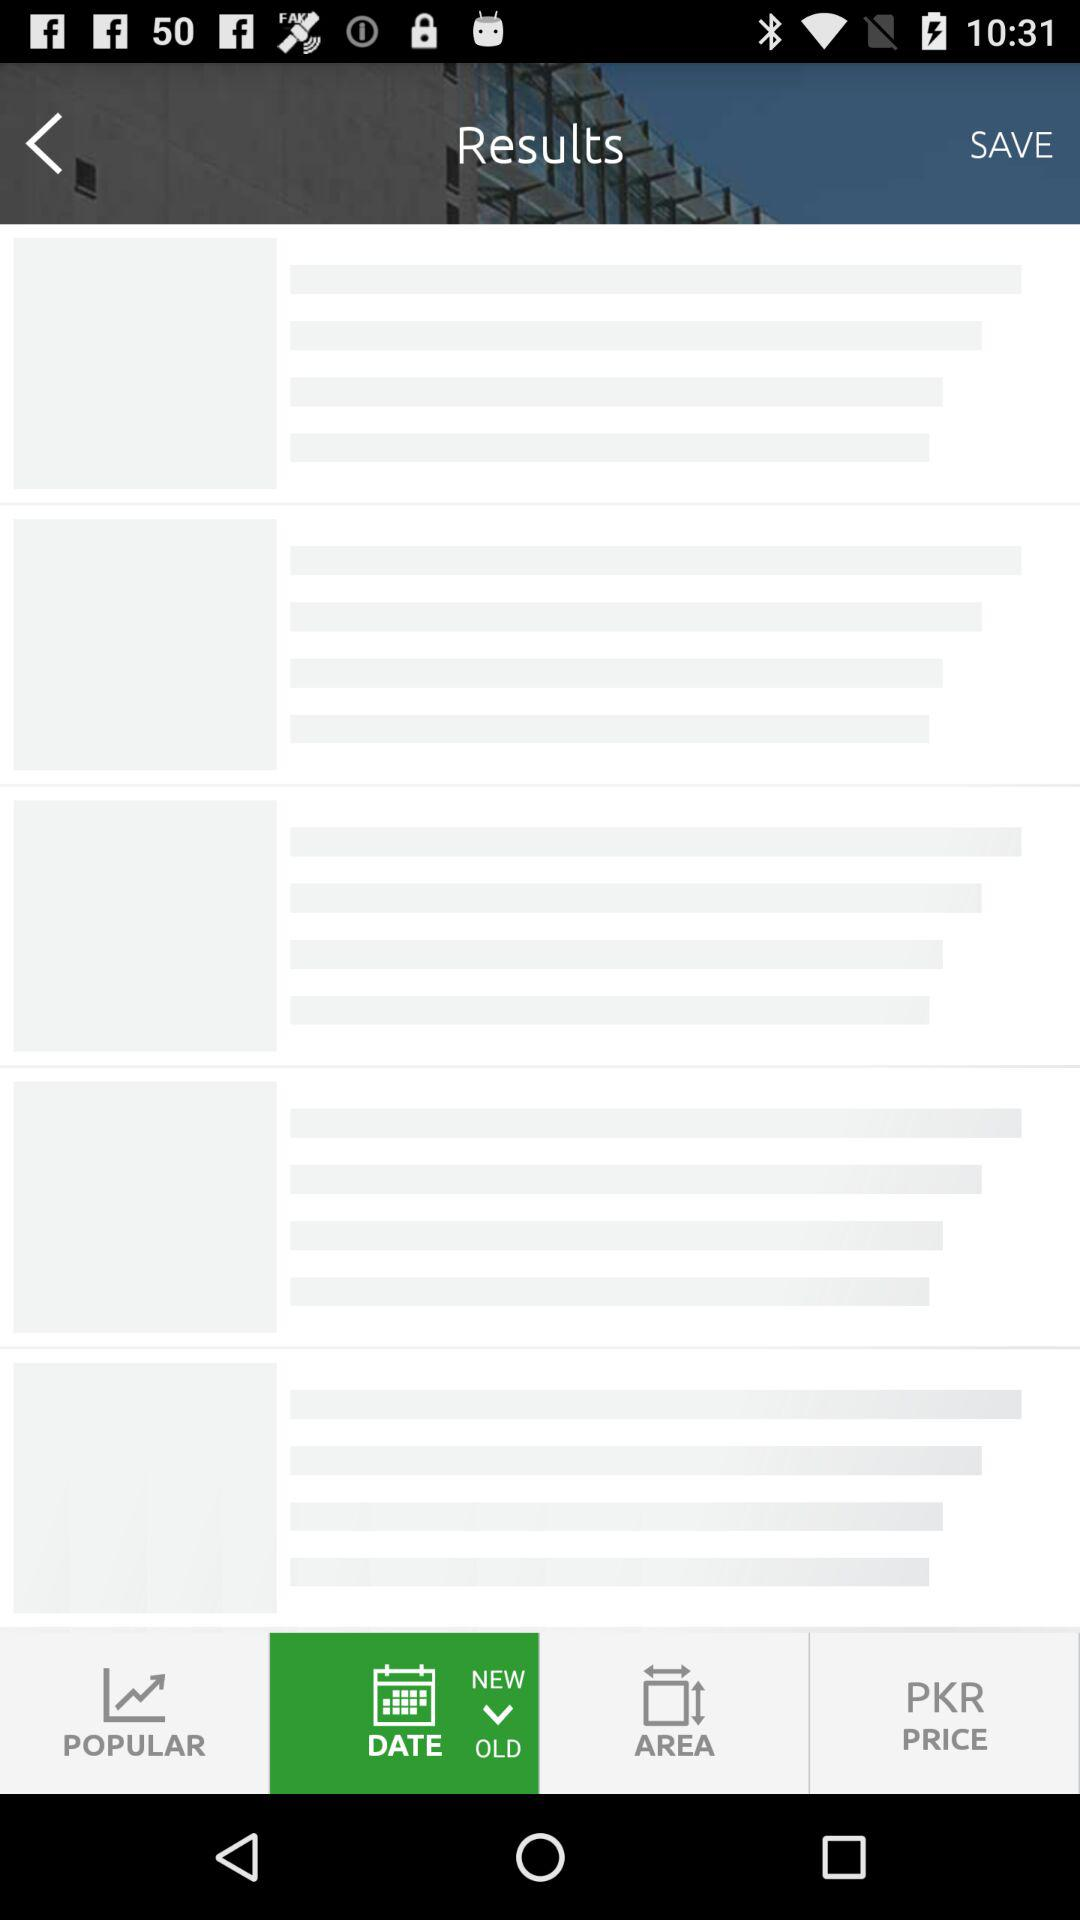How many bedrooms are in the bungalow? There are 5 bedrooms in the bungalow. 